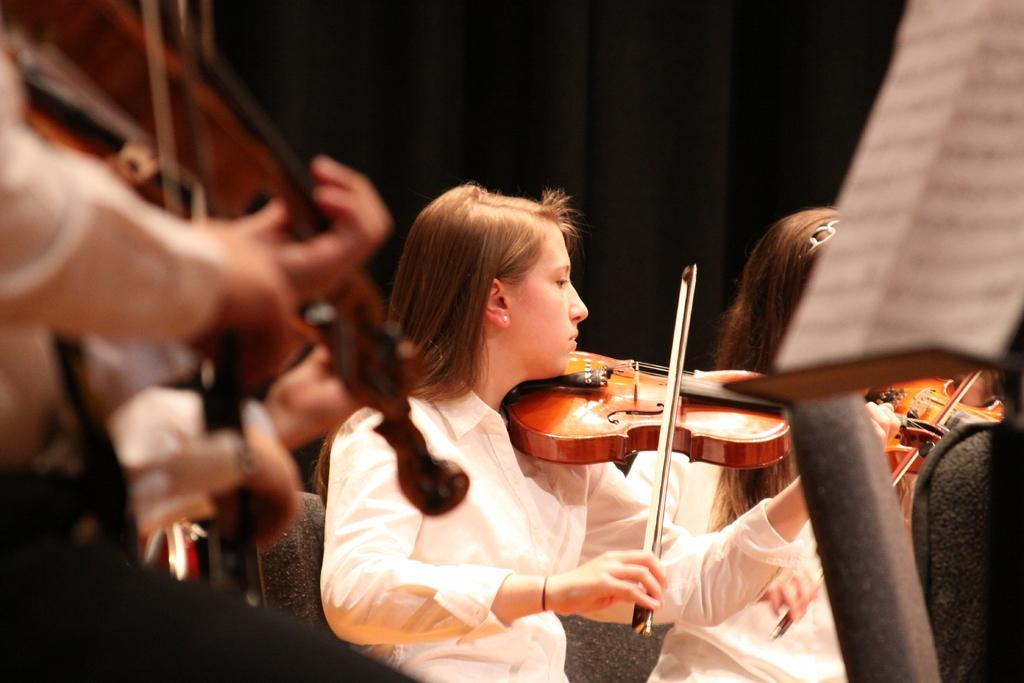How would you summarize this image in a sentence or two? One girl is sitting on the chair holding a violin and playing it and in one hand she is holding the violin stick. Near to her another girl is sitting and playing the violin. 